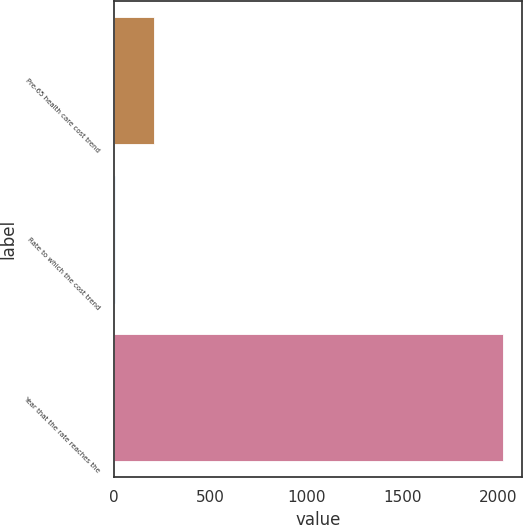Convert chart to OTSL. <chart><loc_0><loc_0><loc_500><loc_500><bar_chart><fcel>Pre-65 health care cost trend<fcel>Rate to which the cost trend<fcel>Year that the rate reaches the<nl><fcel>206.8<fcel>5<fcel>2023<nl></chart> 